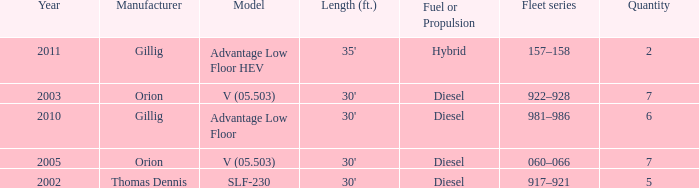Tell me the model with fuel or propulsion of diesel and orion manufacturer in 2005 V (05.503). 